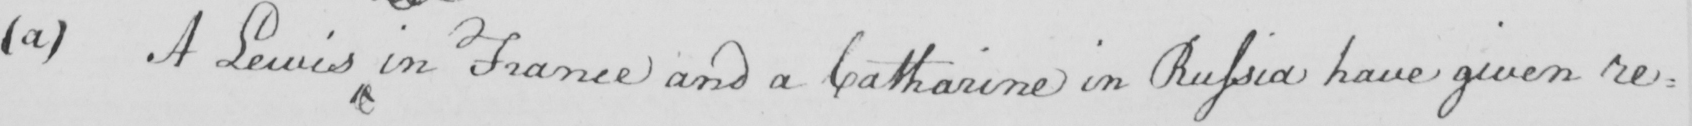What text is written in this handwritten line? ( a )  A Lewis in France and a Catharine in Russia have given re= 